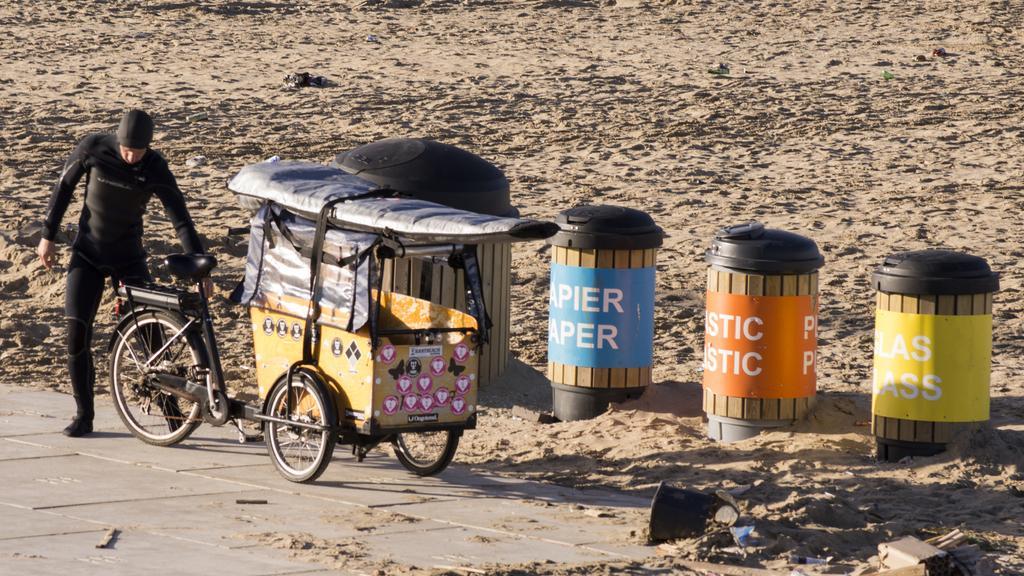Please provide a concise description of this image. In this image ,on the left side there is a person wearing a black dress and standing on the ground and there are different kind of box present on the ground. 